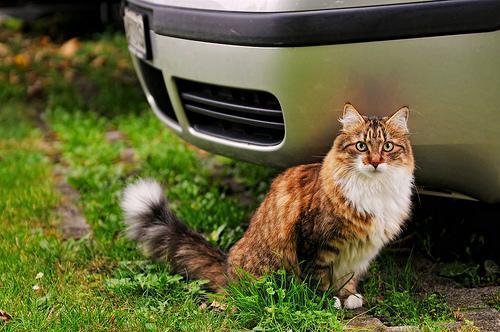How many vehicles are there?
Give a very brief answer. 1. How many animals are in the picture?
Give a very brief answer. 1. 